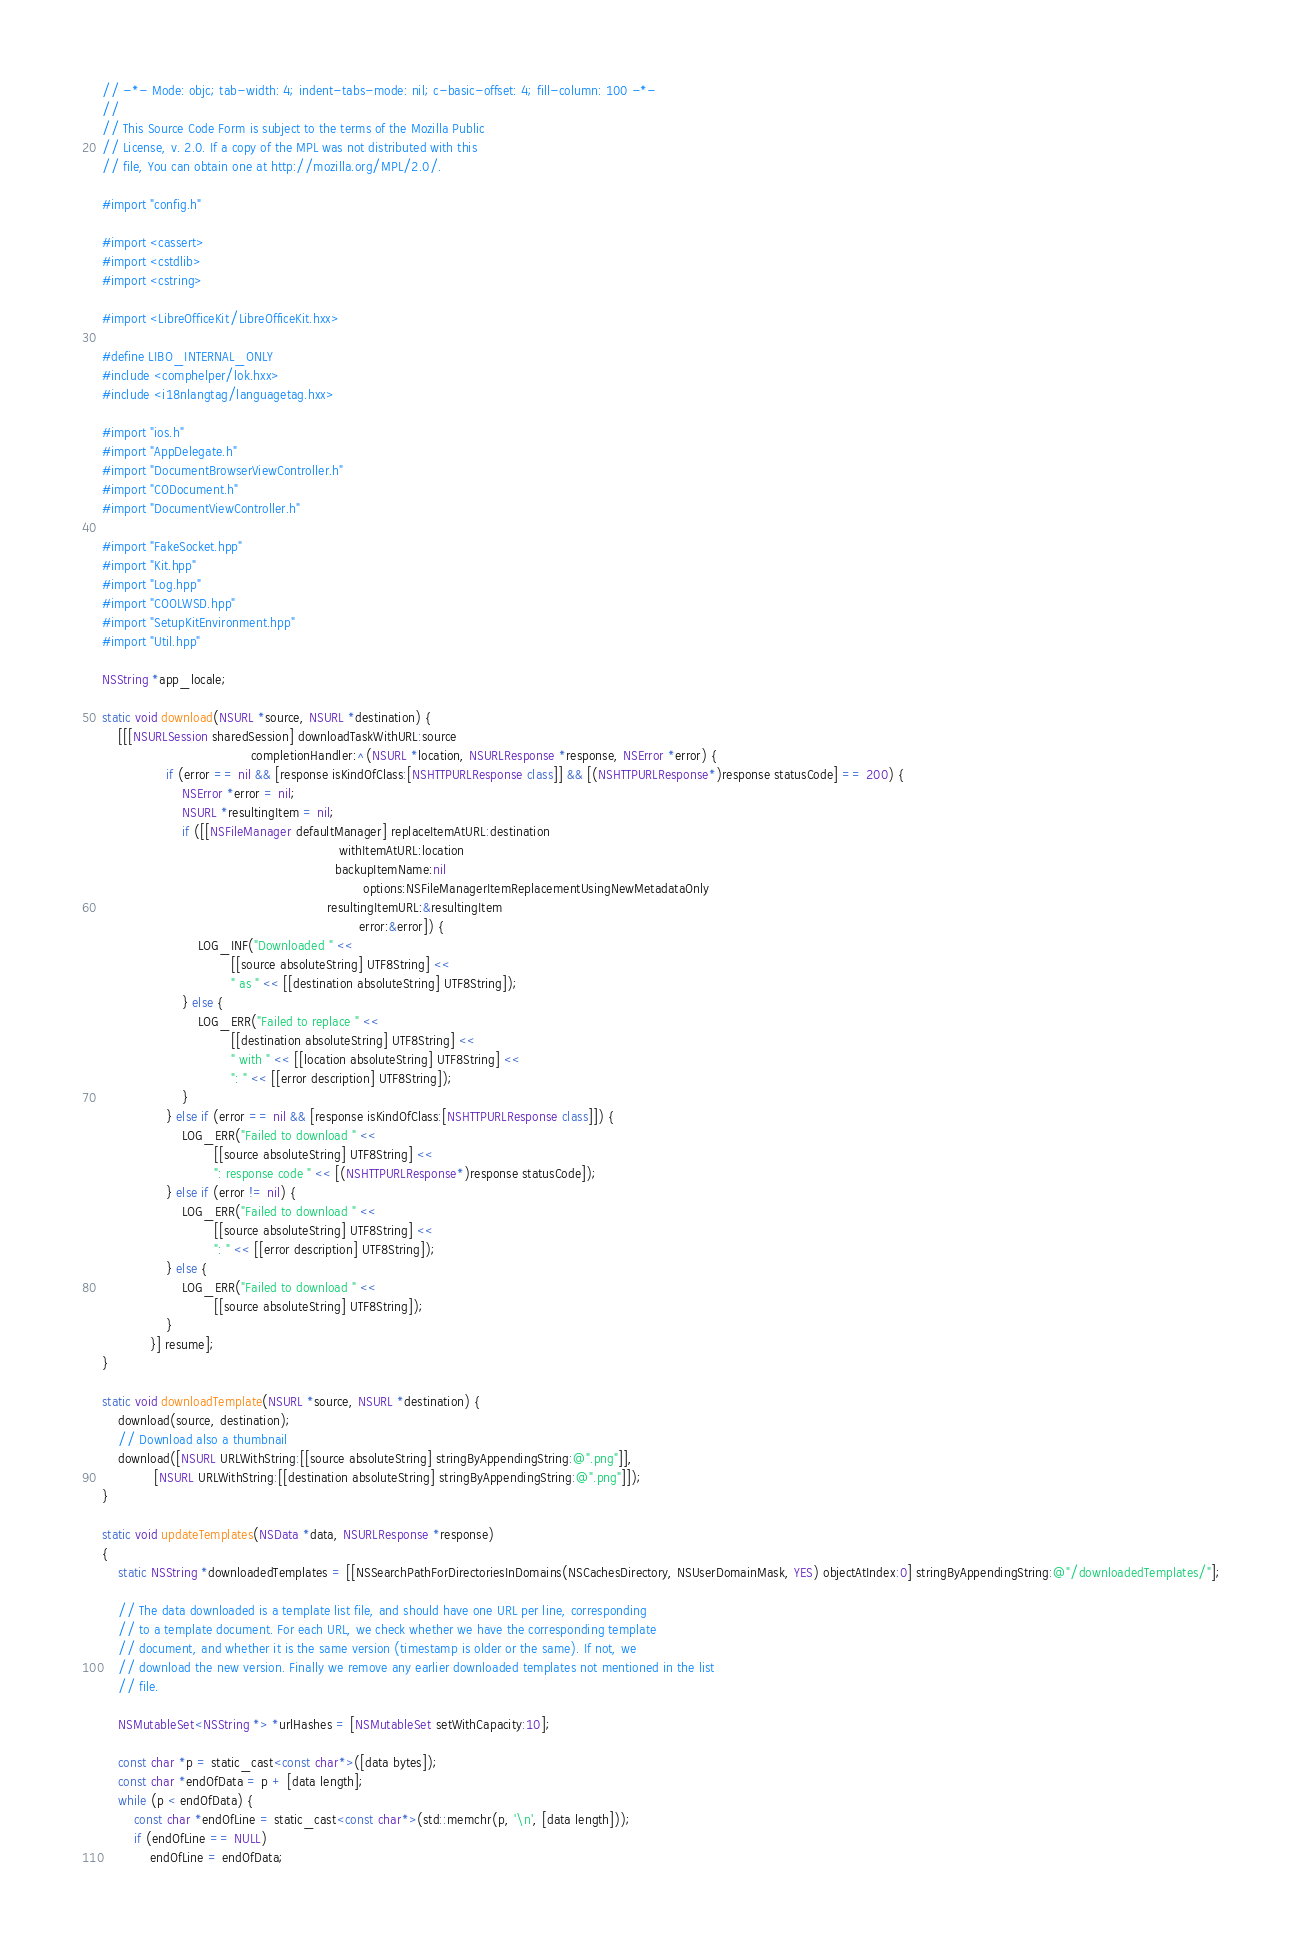Convert code to text. <code><loc_0><loc_0><loc_500><loc_500><_ObjectiveC_>// -*- Mode: objc; tab-width: 4; indent-tabs-mode: nil; c-basic-offset: 4; fill-column: 100 -*-
//
// This Source Code Form is subject to the terms of the Mozilla Public
// License, v. 2.0. If a copy of the MPL was not distributed with this
// file, You can obtain one at http://mozilla.org/MPL/2.0/.

#import "config.h"

#import <cassert>
#import <cstdlib>
#import <cstring>

#import <LibreOfficeKit/LibreOfficeKit.hxx>

#define LIBO_INTERNAL_ONLY
#include <comphelper/lok.hxx>
#include <i18nlangtag/languagetag.hxx>

#import "ios.h"
#import "AppDelegate.h"
#import "DocumentBrowserViewController.h"
#import "CODocument.h"
#import "DocumentViewController.h"

#import "FakeSocket.hpp"
#import "Kit.hpp"
#import "Log.hpp"
#import "COOLWSD.hpp"
#import "SetupKitEnvironment.hpp"
#import "Util.hpp"

NSString *app_locale;

static void download(NSURL *source, NSURL *destination) {
    [[[NSURLSession sharedSession] downloadTaskWithURL:source
                                     completionHandler:^(NSURL *location, NSURLResponse *response, NSError *error) {
                if (error == nil && [response isKindOfClass:[NSHTTPURLResponse class]] && [(NSHTTPURLResponse*)response statusCode] == 200) {
                    NSError *error = nil;
                    NSURL *resultingItem = nil;
                    if ([[NSFileManager defaultManager] replaceItemAtURL:destination
                                                           withItemAtURL:location
                                                          backupItemName:nil
                                                                 options:NSFileManagerItemReplacementUsingNewMetadataOnly
                                                        resultingItemURL:&resultingItem
                                                                error:&error]) {
                        LOG_INF("Downloaded " <<
                                [[source absoluteString] UTF8String] <<
                                " as " << [[destination absoluteString] UTF8String]);
                    } else {
                        LOG_ERR("Failed to replace " <<
                                [[destination absoluteString] UTF8String] <<
                                " with " << [[location absoluteString] UTF8String] <<
                                ": " << [[error description] UTF8String]);
                    }
                } else if (error == nil && [response isKindOfClass:[NSHTTPURLResponse class]]) {
                    LOG_ERR("Failed to download " <<
                            [[source absoluteString] UTF8String] <<
                            ": response code " << [(NSHTTPURLResponse*)response statusCode]);
                } else if (error != nil) {
                    LOG_ERR("Failed to download " <<
                            [[source absoluteString] UTF8String] <<
                            ": " << [[error description] UTF8String]);
                } else {
                    LOG_ERR("Failed to download " <<
                            [[source absoluteString] UTF8String]);
                }
            }] resume];
}

static void downloadTemplate(NSURL *source, NSURL *destination) {
    download(source, destination);
    // Download also a thumbnail
    download([NSURL URLWithString:[[source absoluteString] stringByAppendingString:@".png"]],
             [NSURL URLWithString:[[destination absoluteString] stringByAppendingString:@".png"]]);
}

static void updateTemplates(NSData *data, NSURLResponse *response)
{
    static NSString *downloadedTemplates = [[NSSearchPathForDirectoriesInDomains(NSCachesDirectory, NSUserDomainMask, YES) objectAtIndex:0] stringByAppendingString:@"/downloadedTemplates/"];

    // The data downloaded is a template list file, and should have one URL per line, corresponding
    // to a template document. For each URL, we check whether we have the corresponding template
    // document, and whether it is the same version (timestamp is older or the same). If not, we
    // download the new version. Finally we remove any earlier downloaded templates not mentioned in the list
    // file.

    NSMutableSet<NSString *> *urlHashes = [NSMutableSet setWithCapacity:10];

    const char *p = static_cast<const char*>([data bytes]);
    const char *endOfData = p + [data length];
    while (p < endOfData) {
        const char *endOfLine = static_cast<const char*>(std::memchr(p, '\n', [data length]));
        if (endOfLine == NULL)
            endOfLine = endOfData;
</code> 